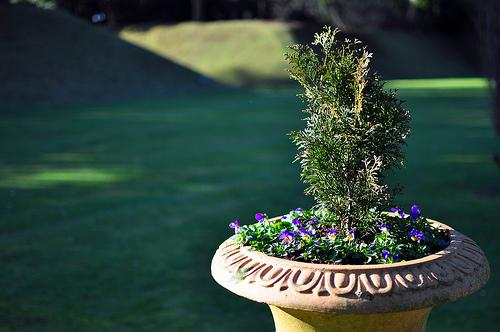Question: what color are the flowers?
Choices:
A. Red.
B. Blue.
C. Purple.
D. White.
Answer with the letter. Answer: C Question: where are the flowers growing in?
Choices:
A. Under the tree.
B. Container.
C. Garden.
D. A pot.
Answer with the letter. Answer: D Question: when are flowers considered mature?
Choices:
A. In bloom.
B. Before they make seeds.
C. End of summer.
D. Before they shed petals.
Answer with the letter. Answer: A Question: who sells flowers for money?
Choices:
A. Gardeners.
B. Flower shops.
C. Artisans sell things made of flowers.
D. Florists.
Answer with the letter. Answer: D Question: how many pots are in the picture?
Choices:
A. 2.
B. 3.
C. 5.
D. 1.
Answer with the letter. Answer: D 